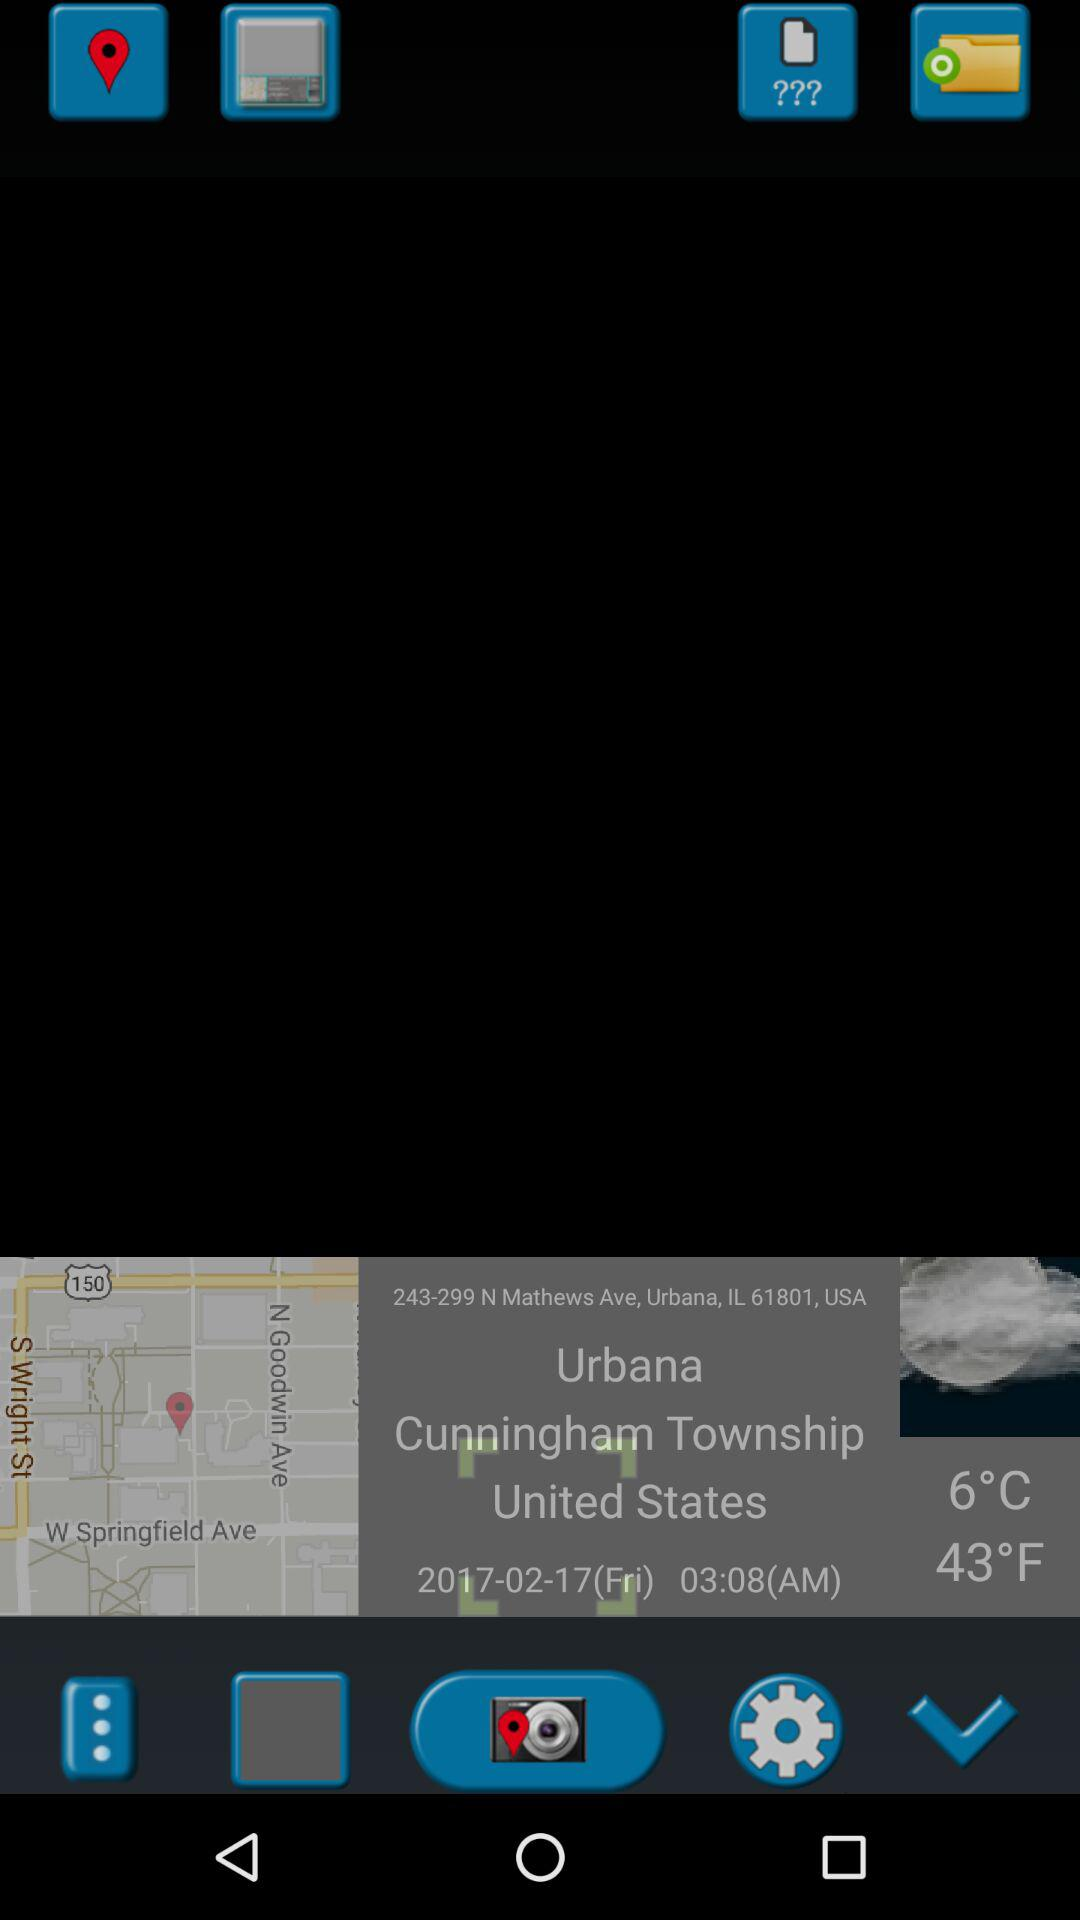How many degrees Fahrenheit is the temperature?
Answer the question using a single word or phrase. 43°F 